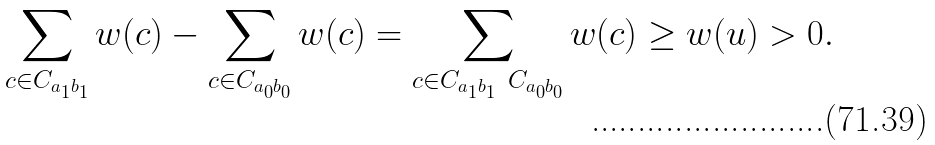<formula> <loc_0><loc_0><loc_500><loc_500>\sum _ { c \in C _ { a _ { 1 } b _ { 1 } } } w ( c ) - \sum _ { c \in C _ { a _ { 0 } b _ { 0 } } } w ( c ) = \sum _ { c \in C _ { a _ { 1 } b _ { 1 } } \ C _ { a _ { 0 } b _ { 0 } } } w ( c ) \geq w ( u ) > 0 .</formula> 